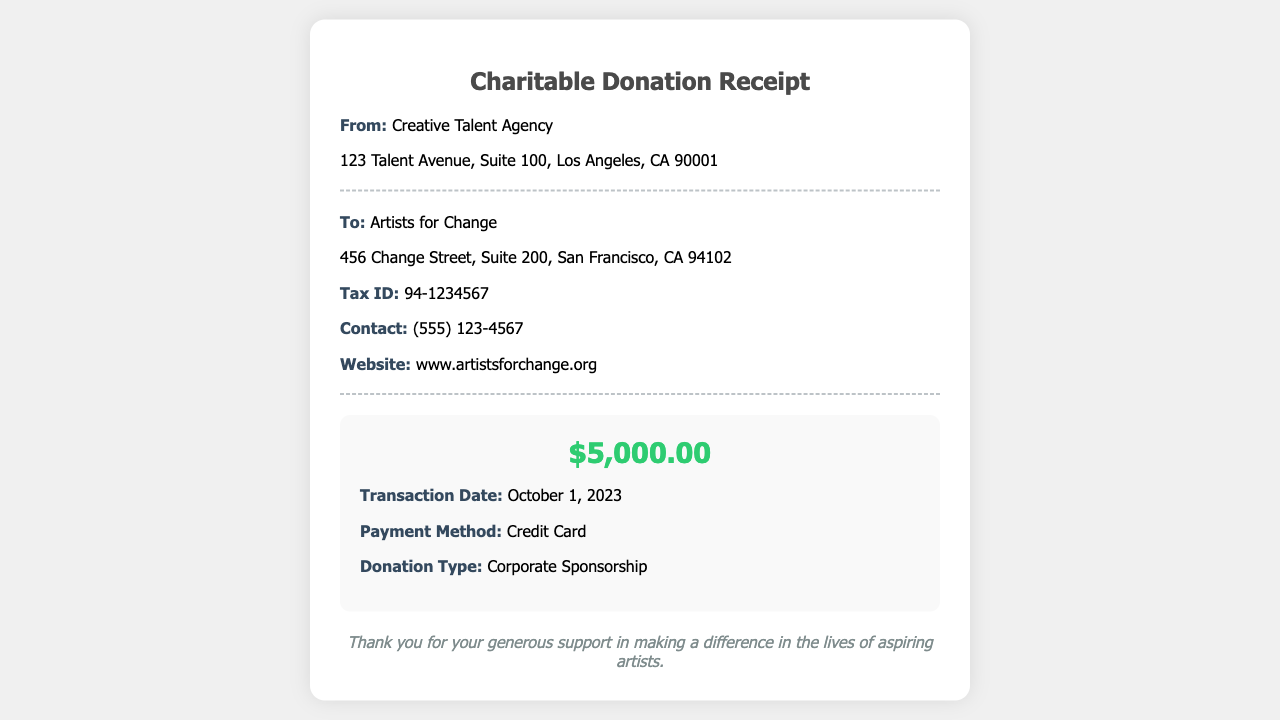What is the donation amount? The donation amount is specified in the donation details section of the receipt.
Answer: $5,000.00 Who is the recipient organization? The recipient organization is mentioned in the "To" section of the document.
Answer: Artists for Change What is the transaction date? The transaction date can be found in the donation details section.
Answer: October 1, 2023 What payment method was used? The payment method is listed in the donation details section of the receipt.
Answer: Credit Card What is the contact number for the recipient organization? The contact number is provided in the organization information section.
Answer: (555) 123-4567 What type of donation is recorded? The type of donation is specified in the donation details section.
Answer: Corporate Sponsorship Where is the Creative Talent Agency located? The location of the Creative Talent Agency is provided in the agency information section.
Answer: 123 Talent Avenue, Suite 100, Los Angeles, CA 90001 What is the website of the recipient organization? The website is listed in the organization information section.
Answer: www.artistsforchange.org What is the Tax ID of the recipient organization? The Tax ID is mentioned in the recipient organization's information.
Answer: 94-1234567 